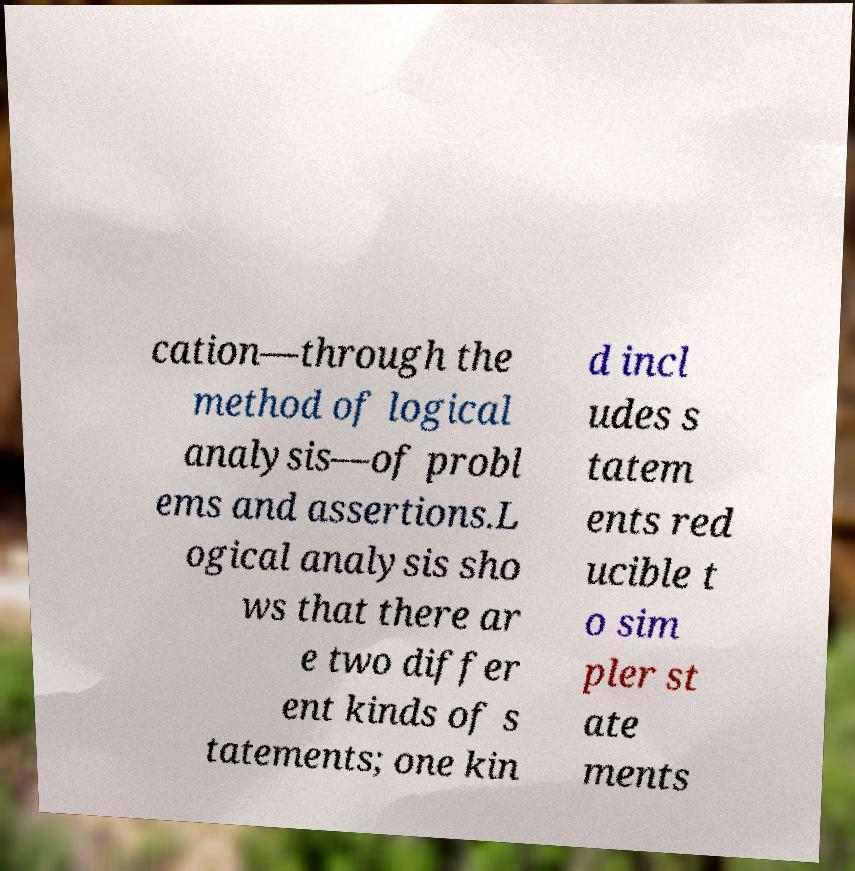I need the written content from this picture converted into text. Can you do that? cation—through the method of logical analysis—of probl ems and assertions.L ogical analysis sho ws that there ar e two differ ent kinds of s tatements; one kin d incl udes s tatem ents red ucible t o sim pler st ate ments 